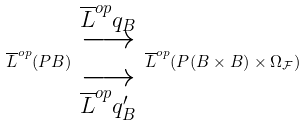Convert formula to latex. <formula><loc_0><loc_0><loc_500><loc_500>\overline { L } ^ { o p } ( P B ) \begin{array} { c } \overset { \overline { L } ^ { o p } q _ { B } } { \longrightarrow } \\ \underset { \overline { L } ^ { o p } q ^ { \prime } _ { B } } { \longrightarrow } \end{array} \overline { L } ^ { o p } ( P ( B \times B ) \times \Omega _ { \mathcal { F } } )</formula> 